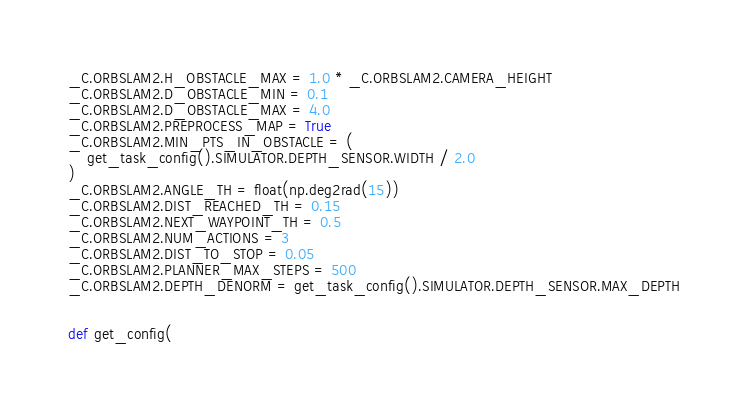Convert code to text. <code><loc_0><loc_0><loc_500><loc_500><_Python_>_C.ORBSLAM2.H_OBSTACLE_MAX = 1.0 * _C.ORBSLAM2.CAMERA_HEIGHT
_C.ORBSLAM2.D_OBSTACLE_MIN = 0.1
_C.ORBSLAM2.D_OBSTACLE_MAX = 4.0
_C.ORBSLAM2.PREPROCESS_MAP = True
_C.ORBSLAM2.MIN_PTS_IN_OBSTACLE = (
    get_task_config().SIMULATOR.DEPTH_SENSOR.WIDTH / 2.0
)
_C.ORBSLAM2.ANGLE_TH = float(np.deg2rad(15))
_C.ORBSLAM2.DIST_REACHED_TH = 0.15
_C.ORBSLAM2.NEXT_WAYPOINT_TH = 0.5
_C.ORBSLAM2.NUM_ACTIONS = 3
_C.ORBSLAM2.DIST_TO_STOP = 0.05
_C.ORBSLAM2.PLANNER_MAX_STEPS = 500
_C.ORBSLAM2.DEPTH_DENORM = get_task_config().SIMULATOR.DEPTH_SENSOR.MAX_DEPTH


def get_config(</code> 